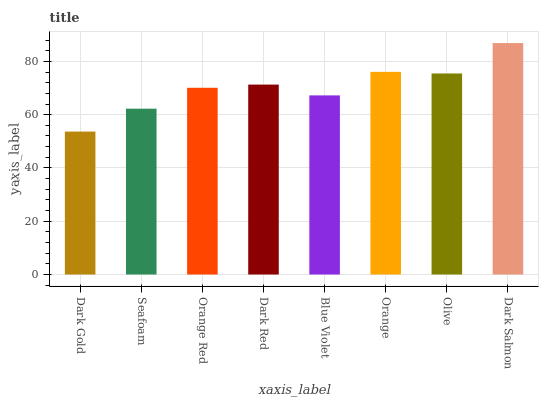Is Dark Gold the minimum?
Answer yes or no. Yes. Is Dark Salmon the maximum?
Answer yes or no. Yes. Is Seafoam the minimum?
Answer yes or no. No. Is Seafoam the maximum?
Answer yes or no. No. Is Seafoam greater than Dark Gold?
Answer yes or no. Yes. Is Dark Gold less than Seafoam?
Answer yes or no. Yes. Is Dark Gold greater than Seafoam?
Answer yes or no. No. Is Seafoam less than Dark Gold?
Answer yes or no. No. Is Dark Red the high median?
Answer yes or no. Yes. Is Orange Red the low median?
Answer yes or no. Yes. Is Dark Salmon the high median?
Answer yes or no. No. Is Dark Red the low median?
Answer yes or no. No. 